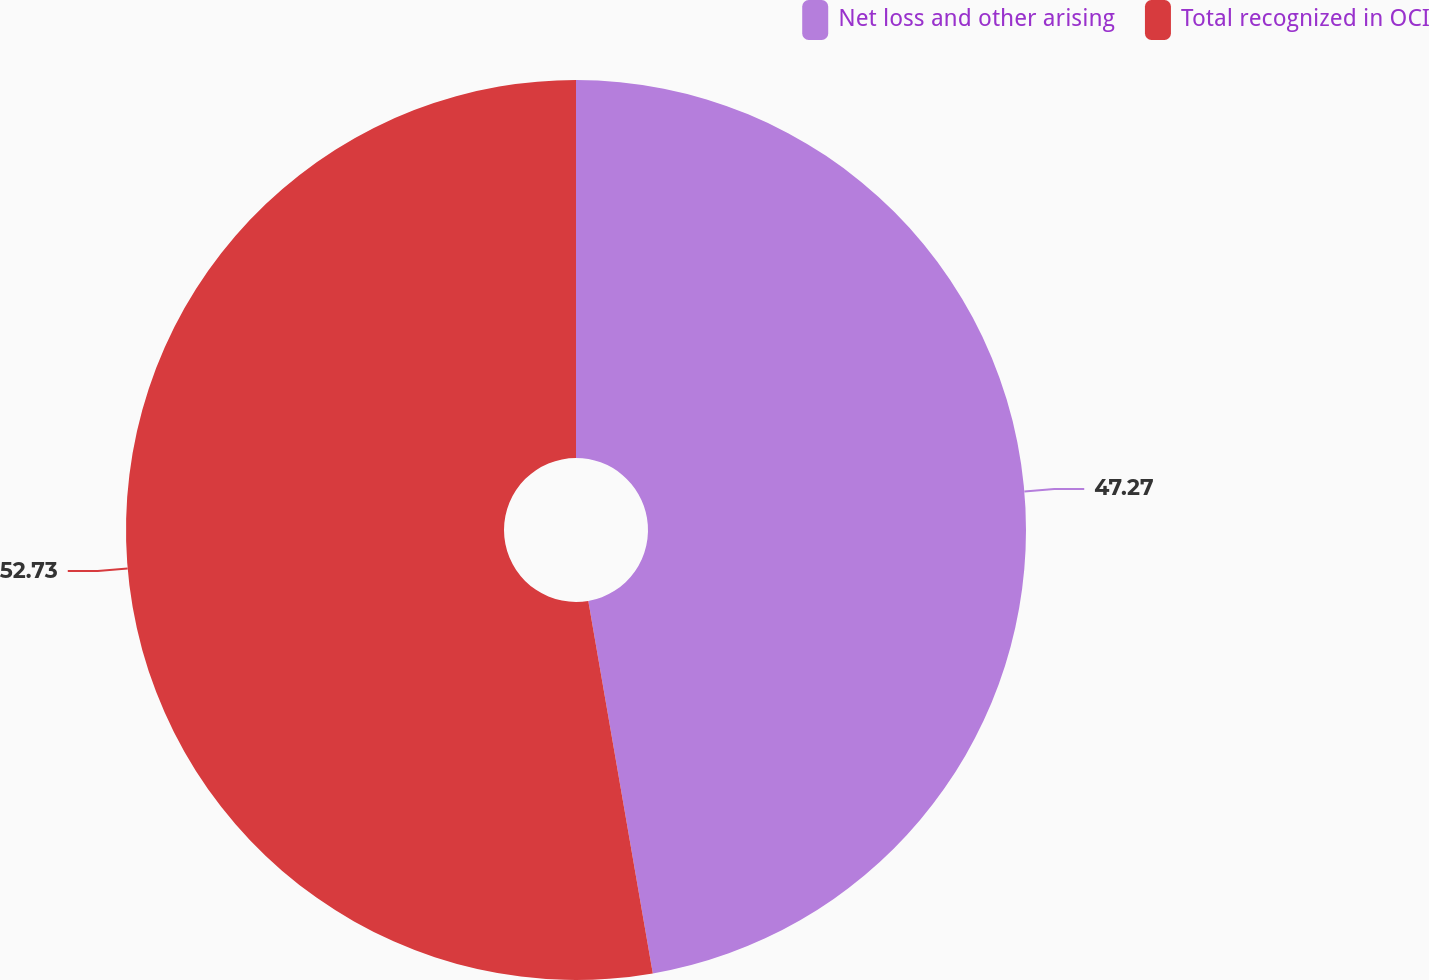Convert chart to OTSL. <chart><loc_0><loc_0><loc_500><loc_500><pie_chart><fcel>Net loss and other arising<fcel>Total recognized in OCI<nl><fcel>47.27%<fcel>52.73%<nl></chart> 